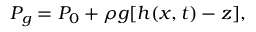<formula> <loc_0><loc_0><loc_500><loc_500>P _ { g } = P _ { 0 } + \rho g [ h ( x , t ) - z ] ,</formula> 